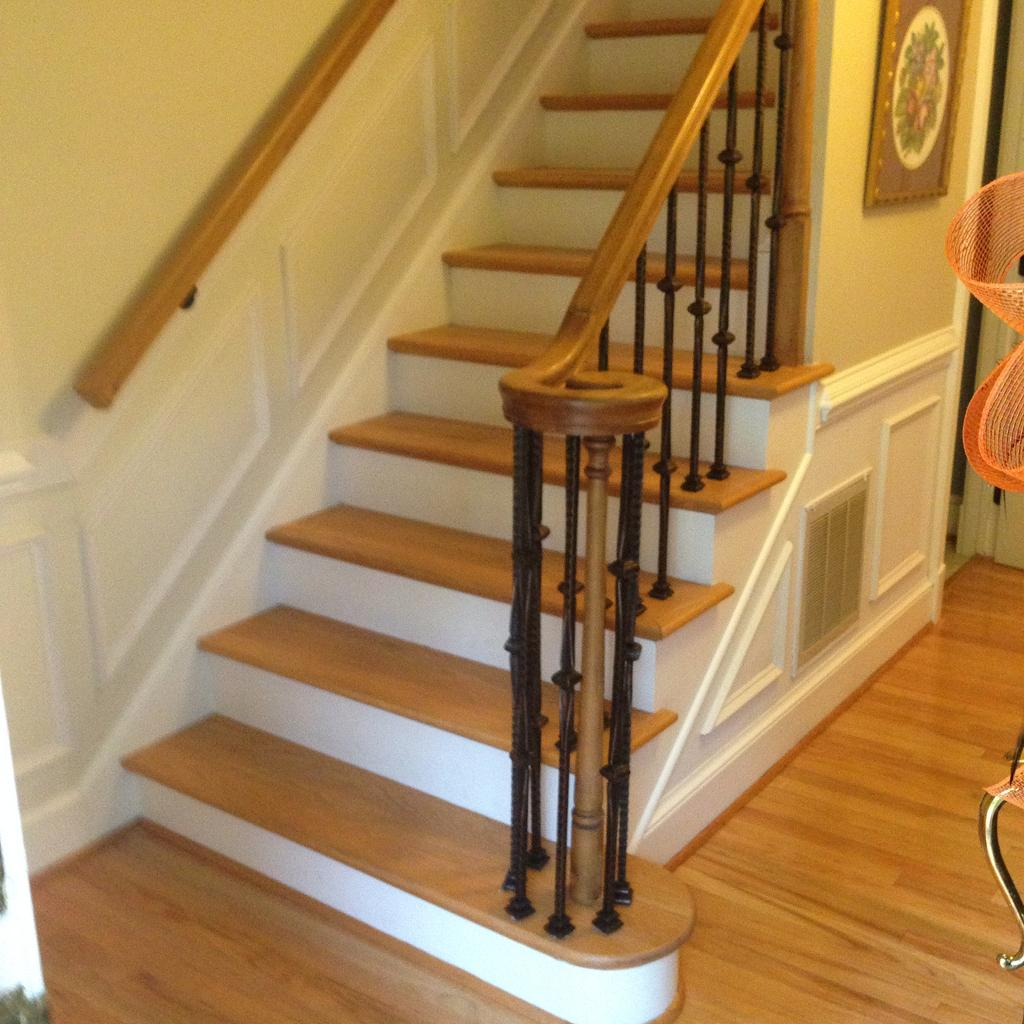What architectural feature is on the left side of the image? There are stairs and a railing on the left side of the image. What is on the right side of the image? There is a wall on the right side of the image. What is hanging on the wall? There is a photo frame on the wall. What is the bottom part of the image made of? The bottom of the image contains the floor. What is the aftermath of the event depicted in the photo frame? There is no event depicted in the photo frame, so there is no aftermath to discuss. What is the tendency of the stairs in the image? The stairs in the image are stationary and do not have a tendency. 